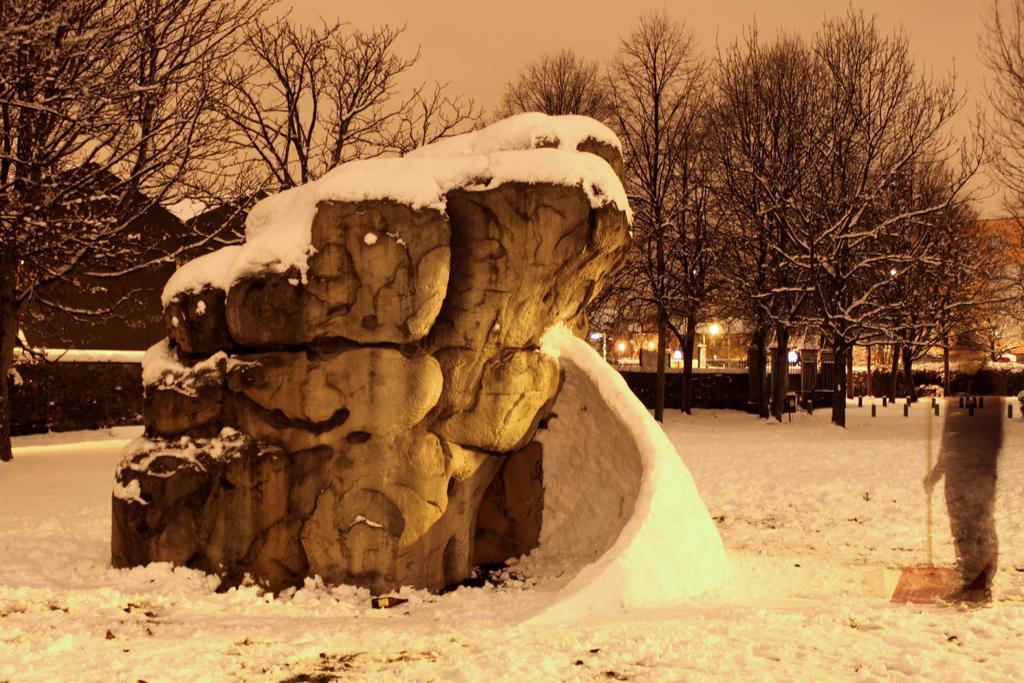Describe this image in one or two sentences. In the center of the image, we can see a rock and it is covered with snow. In the background, there are trees, poles and lights and on the light, we can see a person holding a stick. At the top, there is sky and at the bottom, there is snow. 